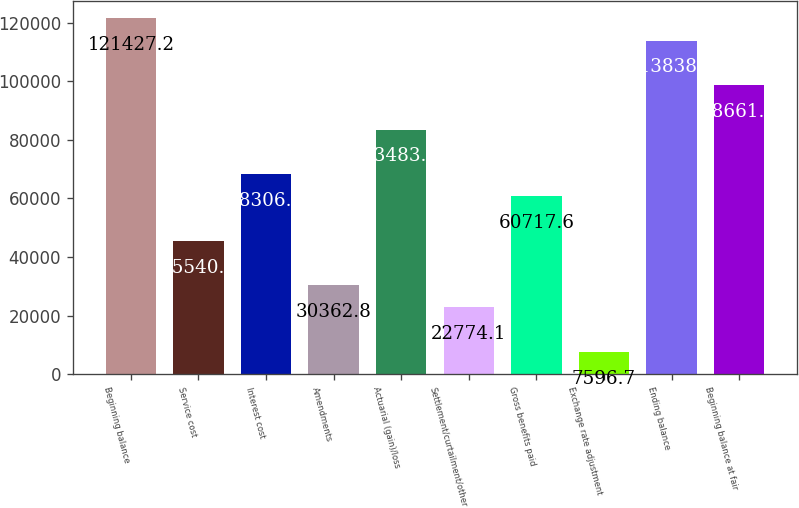Convert chart to OTSL. <chart><loc_0><loc_0><loc_500><loc_500><bar_chart><fcel>Beginning balance<fcel>Service cost<fcel>Interest cost<fcel>Amendments<fcel>Actuarial (gain)/loss<fcel>Settlement/curtailment/other<fcel>Gross benefits paid<fcel>Exchange rate adjustment<fcel>Ending balance<fcel>Beginning balance at fair<nl><fcel>121427<fcel>45540.2<fcel>68306.3<fcel>30362.8<fcel>83483.7<fcel>22774.1<fcel>60717.6<fcel>7596.7<fcel>113838<fcel>98661.1<nl></chart> 